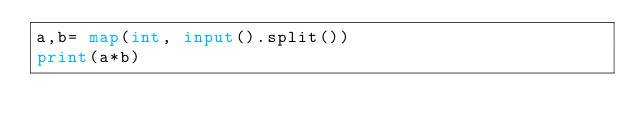Convert code to text. <code><loc_0><loc_0><loc_500><loc_500><_Python_>a,b= map(int, input().split())
print(a*b)</code> 